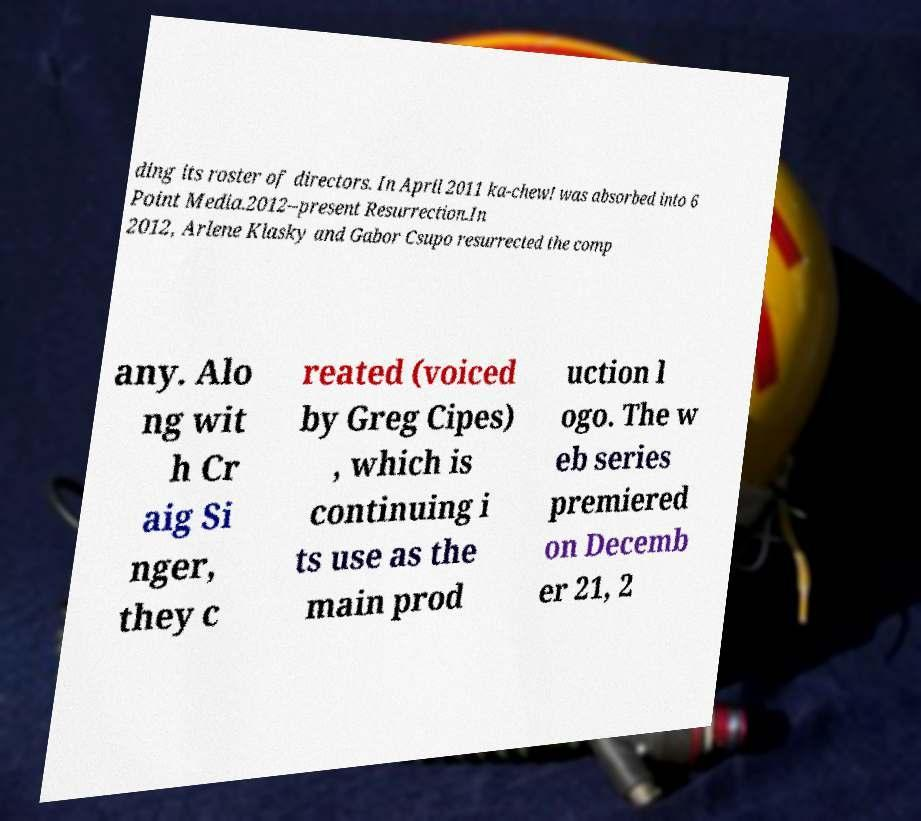I need the written content from this picture converted into text. Can you do that? ding its roster of directors. In April 2011 ka-chew! was absorbed into 6 Point Media.2012–present Resurrection.In 2012, Arlene Klasky and Gabor Csupo resurrected the comp any. Alo ng wit h Cr aig Si nger, they c reated (voiced by Greg Cipes) , which is continuing i ts use as the main prod uction l ogo. The w eb series premiered on Decemb er 21, 2 